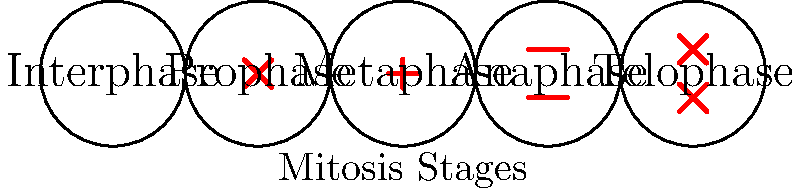In the diagram of plant cell mitosis, which stage is most likely to be misidentified by an AI system due to its similarity with another stage, and why might a botanist find this amusing? Step 1: Analyze each stage of mitosis in the diagram:
- Interphase: No visible chromosomes
- Prophase: Chromosomes start to condense
- Metaphase: Chromosomes align at the equator
- Anaphase: Chromosomes separate and move to opposite poles
- Telophase: Two nuclei form, and cytokinesis begins

Step 2: Identify stages with similar appearances:
Prophase and Telophase both show condensed chromosomes, but their arrangement differs.

Step 3: Consider AI limitations:
AI systems might struggle to differentiate between subtle differences in chromosome arrangement and nuclear envelope status.

Step 4: Relate to botanist's perspective:
A botanist would find it amusing that an AI system might confuse Prophase and Telophase, as these stages represent opposite ends of the mitosis process.

Step 5: Conclude:
Prophase and Telophase are most likely to be misidentified by an AI system due to their similar appearance of condensed chromosomes, despite representing the beginning and end of mitosis, respectively.
Answer: Prophase and Telophase 